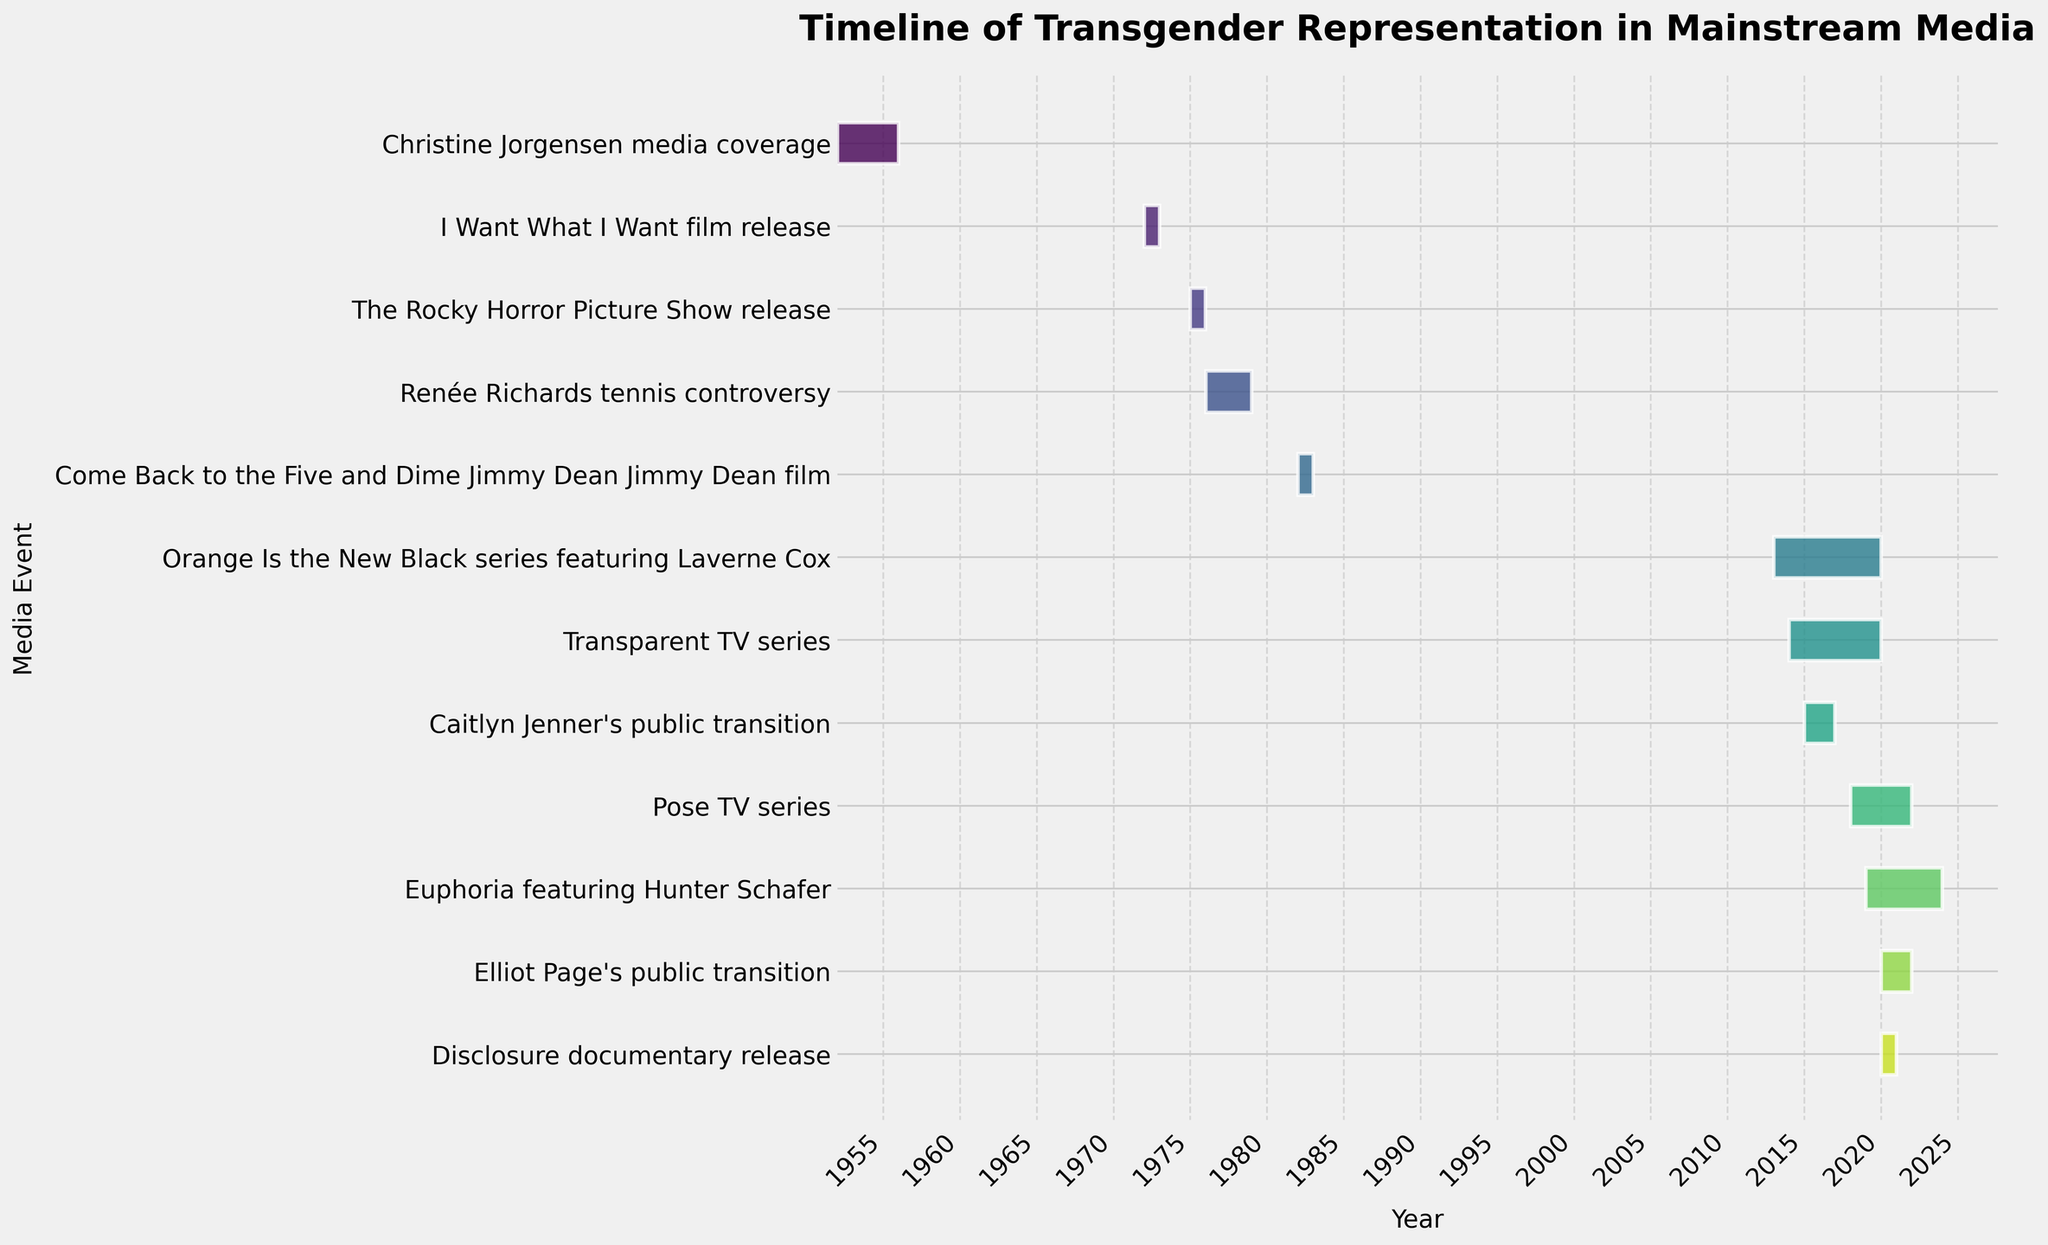What is the title of the figure? The title of the figure is the text displayed at the top in bold and larger font size. By looking at the top of the plot, you can see the title: "Timeline of Transgender Representation in Mainstream Media".
Answer: Timeline of Transgender Representation in Mainstream Media Which event has the earliest start date? To find the event with the earliest start date, you need to look at the leftmost bar on the plot, which corresponds to the earliest year. The earliest event starts in 1952, which is "Christine Jorgensen media coverage".
Answer: Christine Jorgensen media coverage How many media representations started in the 1970s? Identify the events represented by the bars that start between 1970 and 1979 by reading the year labels on the x-axis. There are three such events: "I Want What I Want" film release (1972), "The Rocky Horror Picture Show" release (1975), and "Renée Richards tennis controversy" (1976).
Answer: Three Which event has the longest duration? Measure the length of each bar from start to end dates. The longest bar represents the event that spans the most years. "Euphoria" featuring Hunter Schafer (2019-2023) is the event with the longest duration.
Answer: Euphoria featuring Hunter Schafer What events occurred during the 2010s? Examine bars that fall within the range of dates from 2010 to 2019 on the x-axis. The events are: "Orange Is the New Black" series featuring Laverne Cox (2013-2019), "Transparent" TV series (2014-2019), and Caitlyn Jenner's public transition (2015-2016).
Answer: Orange Is the New Black, Transparent, Caitlyn Jenner's public transition Which two events have overlapping timelines? Look for bars that start and end within the same range of years. Both "Euphoria" (2019-2023) and "Pose" (2018-2021) overlap from 2019 to 2021.
Answer: Euphoria and Pose What is the duration of Caitlyn Jenner's public transition? To calculate the duration, subtract the start year from the end year for "Caitlyn Jenner's public transition". The transition spans from 2015 to 2016, so the duration is 1 year.
Answer: 1 year How many events have a duration of 1 year? Look for bars that start and end in the same year. These events are: "I Want What I Want" film release (1972), "The Rocky Horror Picture Show" release (1975), "Come Back to the Five and Dime Jimmy Dean Jimmy Dean" film (1982), "Disclosure" documentary release (2020).
Answer: Four 